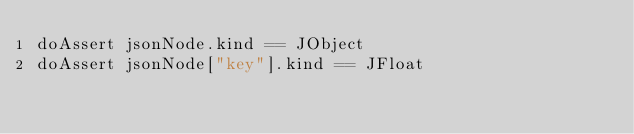Convert code to text. <code><loc_0><loc_0><loc_500><loc_500><_Nim_>doAssert jsonNode.kind == JObject
doAssert jsonNode["key"].kind == JFloat
</code> 